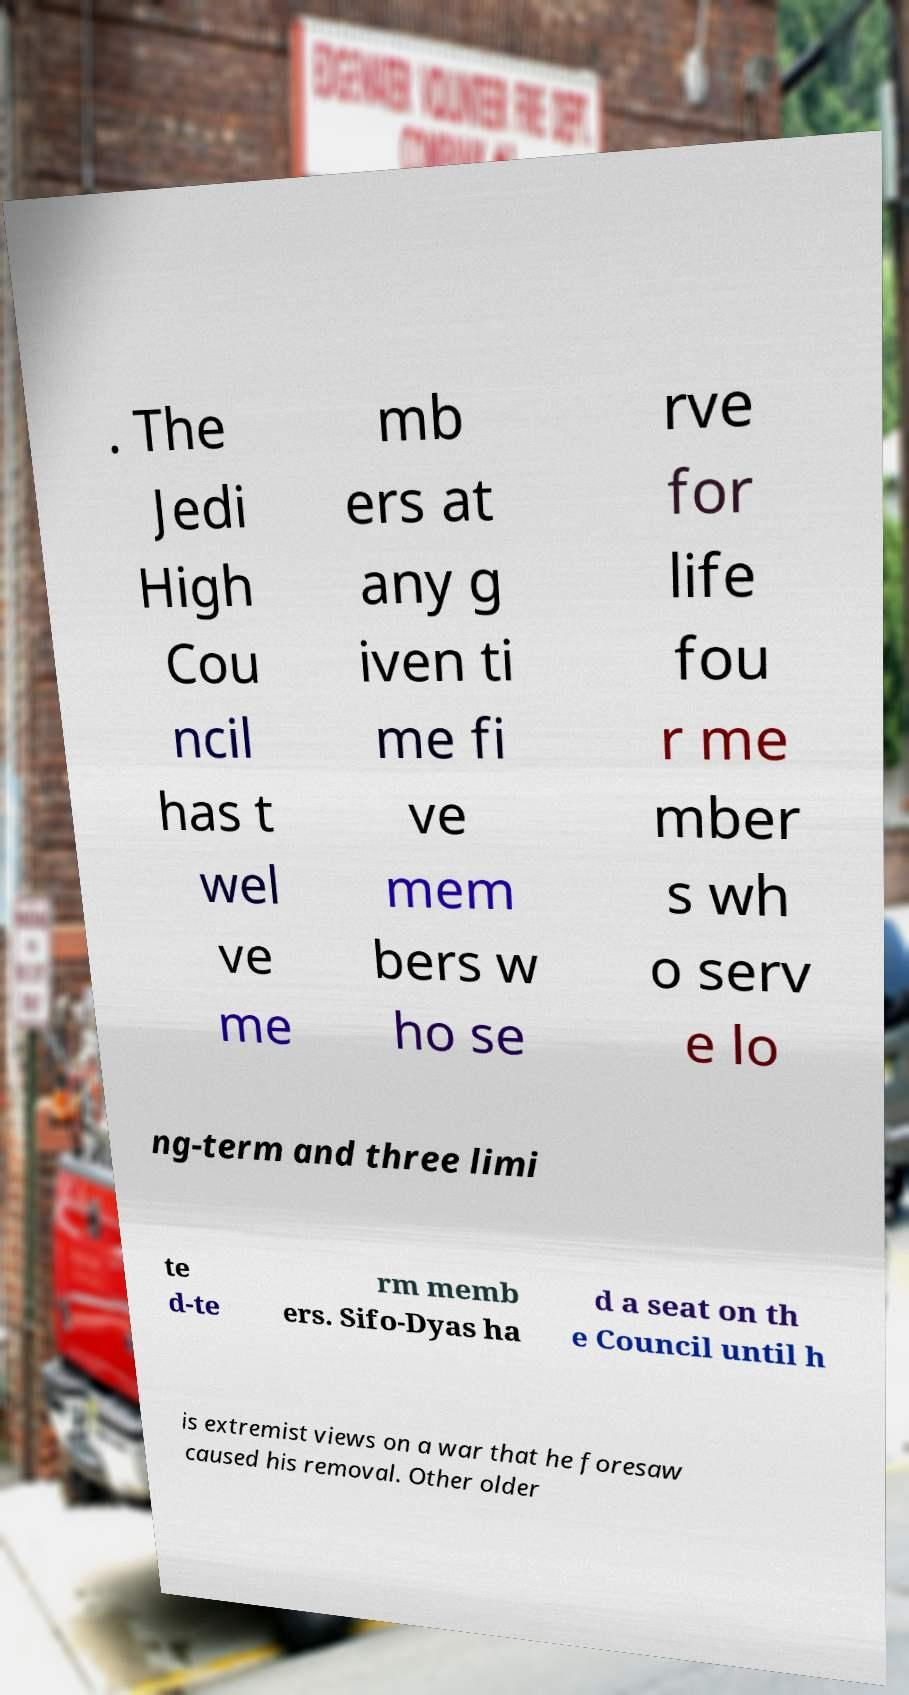Could you extract and type out the text from this image? . The Jedi High Cou ncil has t wel ve me mb ers at any g iven ti me fi ve mem bers w ho se rve for life fou r me mber s wh o serv e lo ng-term and three limi te d-te rm memb ers. Sifo-Dyas ha d a seat on th e Council until h is extremist views on a war that he foresaw caused his removal. Other older 